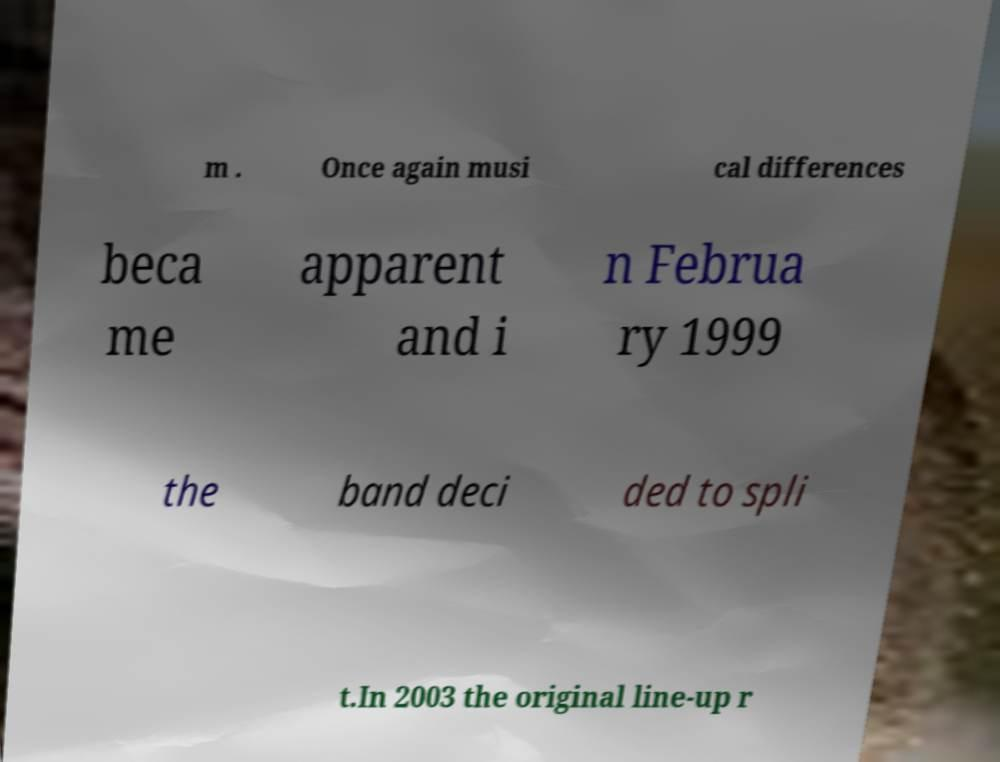Please read and relay the text visible in this image. What does it say? m . Once again musi cal differences beca me apparent and i n Februa ry 1999 the band deci ded to spli t.In 2003 the original line-up r 